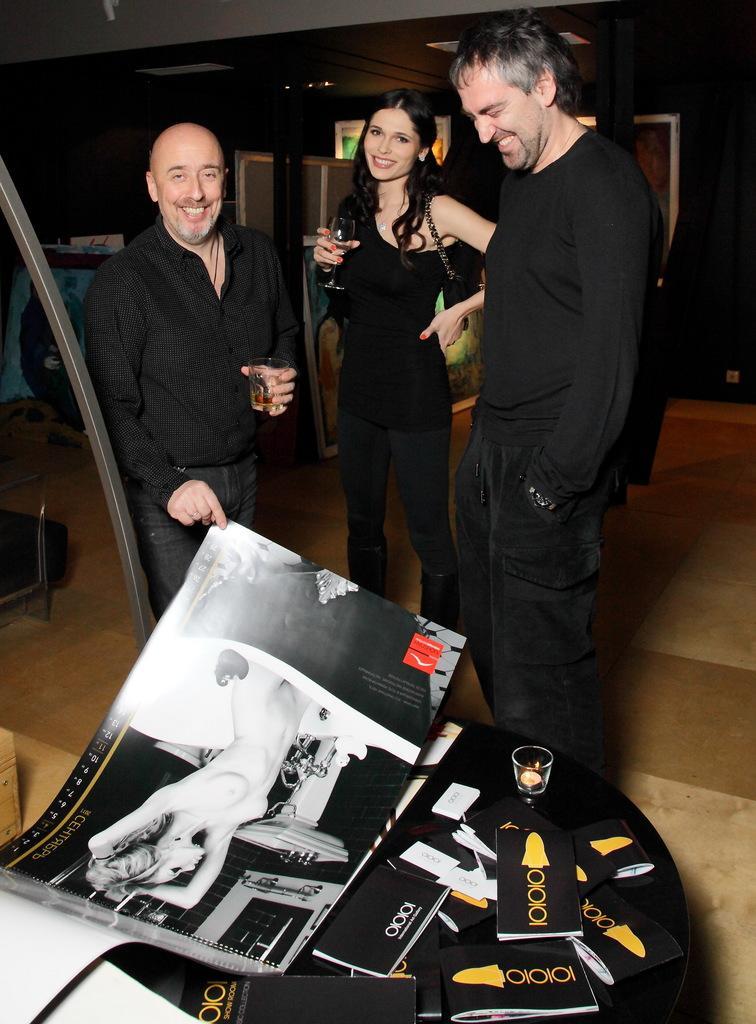Please provide a concise description of this image. In this image we can see a group of people standing on the floor one person is holding a glass in his hand. One women wearing the bag. In the foreground of the image we can see the table on which group of books, poster, candle are placed. In the background, we can see lights, poles. 